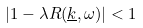Convert formula to latex. <formula><loc_0><loc_0><loc_500><loc_500>| 1 - \lambda R ( \underline { k } , \omega ) | < 1</formula> 